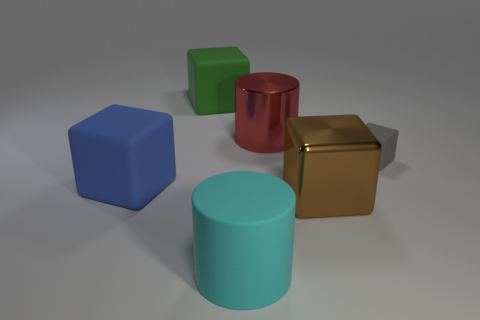Subtract all matte cubes. How many cubes are left? 1 Subtract all brown blocks. How many blocks are left? 3 Add 3 tiny metal blocks. How many objects exist? 9 Subtract 2 cubes. How many cubes are left? 2 Subtract all purple blocks. Subtract all red balls. How many blocks are left? 4 Subtract all cylinders. How many objects are left? 4 Subtract 1 red cylinders. How many objects are left? 5 Subtract all gray matte cylinders. Subtract all brown metallic things. How many objects are left? 5 Add 2 big rubber cubes. How many big rubber cubes are left? 4 Add 6 blocks. How many blocks exist? 10 